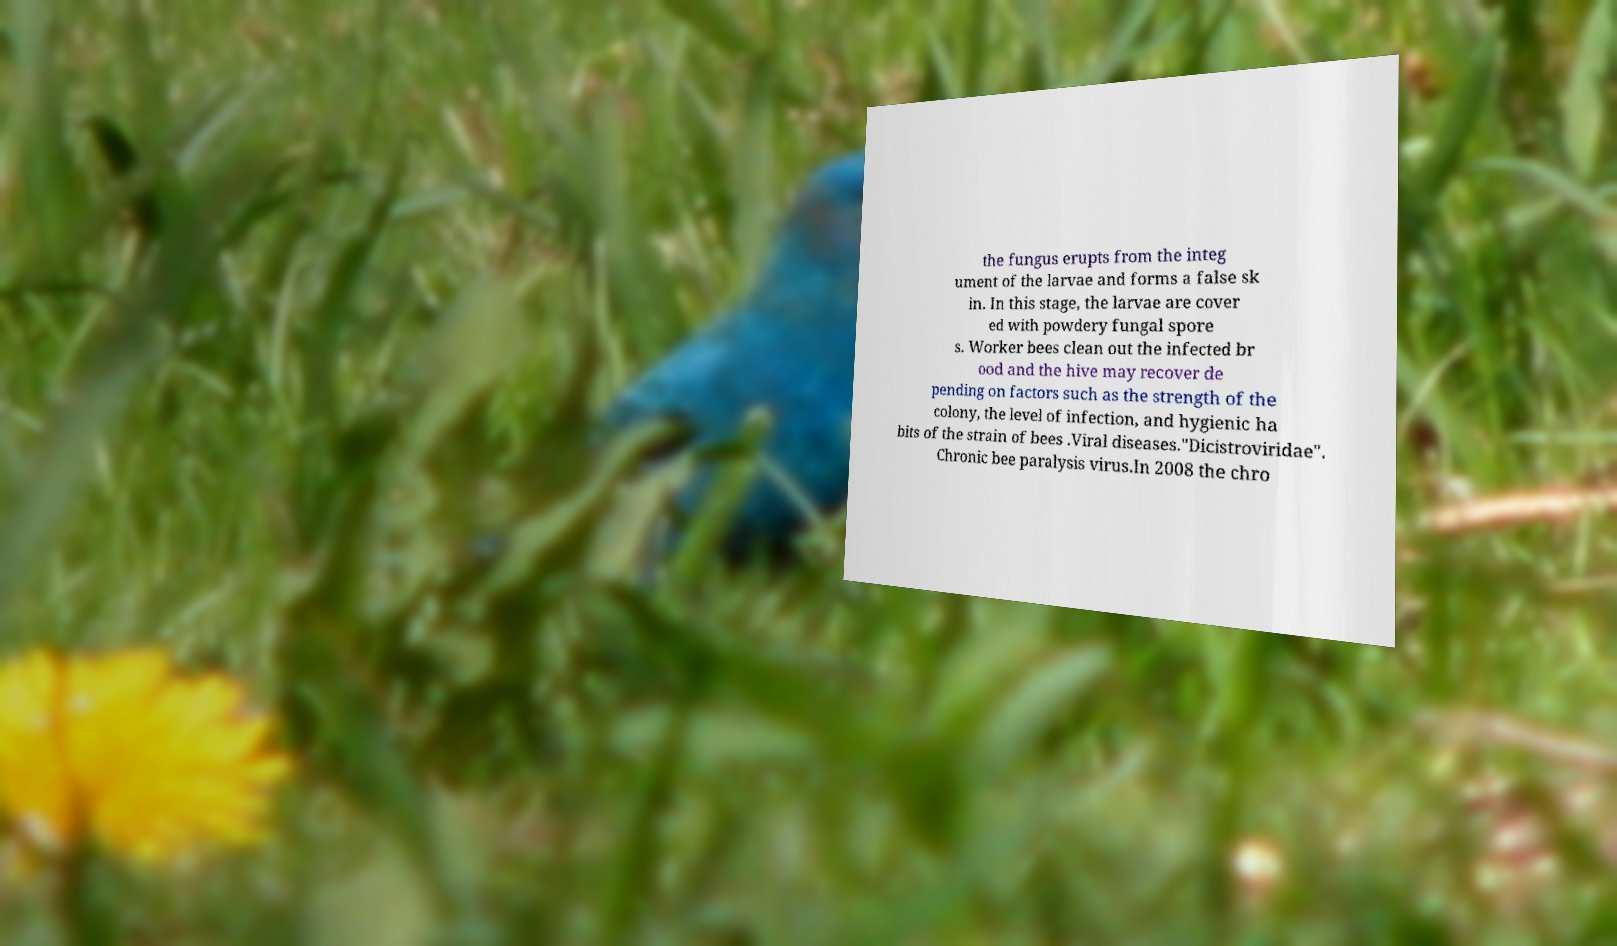For documentation purposes, I need the text within this image transcribed. Could you provide that? the fungus erupts from the integ ument of the larvae and forms a false sk in. In this stage, the larvae are cover ed with powdery fungal spore s. Worker bees clean out the infected br ood and the hive may recover de pending on factors such as the strength of the colony, the level of infection, and hygienic ha bits of the strain of bees .Viral diseases."Dicistroviridae". Chronic bee paralysis virus.In 2008 the chro 